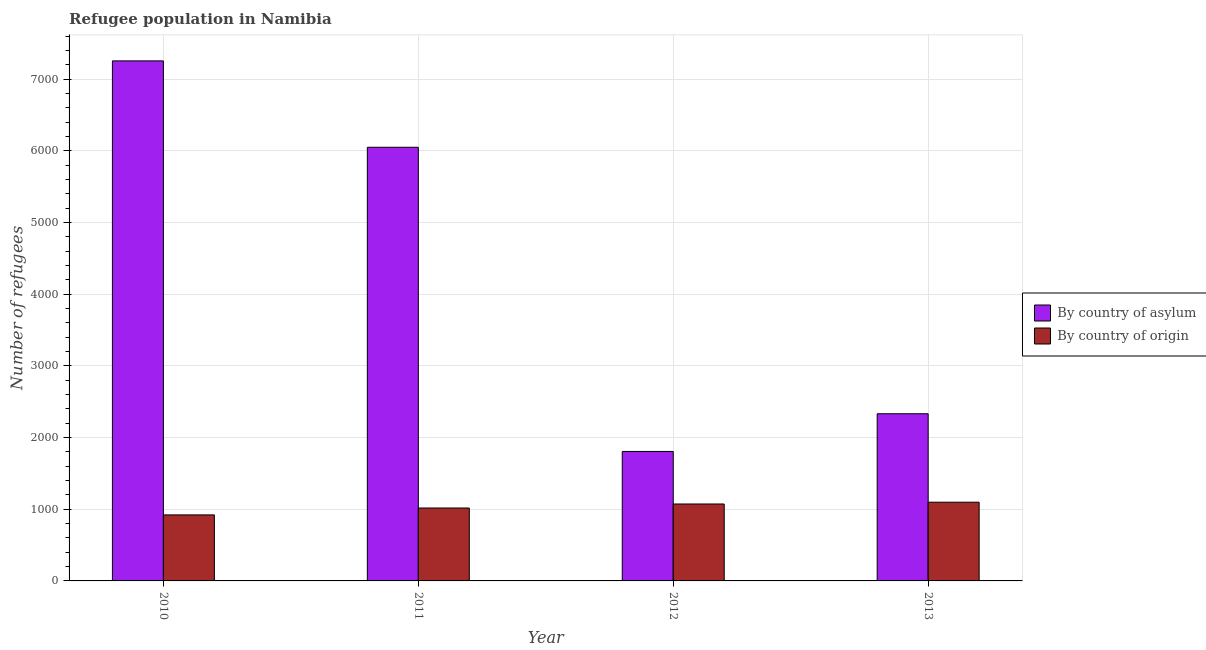How many different coloured bars are there?
Give a very brief answer. 2. Are the number of bars per tick equal to the number of legend labels?
Your answer should be compact. Yes. Are the number of bars on each tick of the X-axis equal?
Ensure brevity in your answer.  Yes. How many bars are there on the 2nd tick from the left?
Keep it short and to the point. 2. How many bars are there on the 1st tick from the right?
Make the answer very short. 2. What is the number of refugees by country of origin in 2010?
Provide a succinct answer. 921. Across all years, what is the maximum number of refugees by country of origin?
Provide a succinct answer. 1098. Across all years, what is the minimum number of refugees by country of asylum?
Your answer should be very brief. 1806. In which year was the number of refugees by country of asylum minimum?
Give a very brief answer. 2012. What is the total number of refugees by country of origin in the graph?
Give a very brief answer. 4109. What is the difference between the number of refugees by country of asylum in 2010 and that in 2012?
Keep it short and to the point. 5448. What is the difference between the number of refugees by country of asylum in 2012 and the number of refugees by country of origin in 2013?
Ensure brevity in your answer.  -526. What is the average number of refugees by country of origin per year?
Give a very brief answer. 1027.25. What is the ratio of the number of refugees by country of origin in 2010 to that in 2012?
Ensure brevity in your answer.  0.86. Is the number of refugees by country of origin in 2010 less than that in 2012?
Your answer should be very brief. Yes. What is the difference between the highest and the lowest number of refugees by country of origin?
Your answer should be compact. 177. What does the 2nd bar from the left in 2013 represents?
Your response must be concise. By country of origin. What does the 2nd bar from the right in 2010 represents?
Ensure brevity in your answer.  By country of asylum. How many bars are there?
Offer a terse response. 8. Are all the bars in the graph horizontal?
Ensure brevity in your answer.  No. What is the difference between two consecutive major ticks on the Y-axis?
Offer a very short reply. 1000. Are the values on the major ticks of Y-axis written in scientific E-notation?
Make the answer very short. No. Does the graph contain any zero values?
Offer a very short reply. No. Does the graph contain grids?
Provide a succinct answer. Yes. How many legend labels are there?
Give a very brief answer. 2. How are the legend labels stacked?
Give a very brief answer. Vertical. What is the title of the graph?
Provide a succinct answer. Refugee population in Namibia. What is the label or title of the Y-axis?
Offer a terse response. Number of refugees. What is the Number of refugees of By country of asylum in 2010?
Offer a terse response. 7254. What is the Number of refugees in By country of origin in 2010?
Provide a short and direct response. 921. What is the Number of refugees of By country of asylum in 2011?
Offer a very short reply. 6049. What is the Number of refugees in By country of origin in 2011?
Provide a short and direct response. 1017. What is the Number of refugees in By country of asylum in 2012?
Offer a terse response. 1806. What is the Number of refugees of By country of origin in 2012?
Your response must be concise. 1073. What is the Number of refugees in By country of asylum in 2013?
Offer a very short reply. 2332. What is the Number of refugees in By country of origin in 2013?
Give a very brief answer. 1098. Across all years, what is the maximum Number of refugees in By country of asylum?
Offer a terse response. 7254. Across all years, what is the maximum Number of refugees of By country of origin?
Your answer should be compact. 1098. Across all years, what is the minimum Number of refugees in By country of asylum?
Give a very brief answer. 1806. Across all years, what is the minimum Number of refugees in By country of origin?
Offer a very short reply. 921. What is the total Number of refugees of By country of asylum in the graph?
Ensure brevity in your answer.  1.74e+04. What is the total Number of refugees of By country of origin in the graph?
Your answer should be compact. 4109. What is the difference between the Number of refugees of By country of asylum in 2010 and that in 2011?
Give a very brief answer. 1205. What is the difference between the Number of refugees of By country of origin in 2010 and that in 2011?
Your answer should be very brief. -96. What is the difference between the Number of refugees of By country of asylum in 2010 and that in 2012?
Your answer should be very brief. 5448. What is the difference between the Number of refugees of By country of origin in 2010 and that in 2012?
Ensure brevity in your answer.  -152. What is the difference between the Number of refugees of By country of asylum in 2010 and that in 2013?
Your answer should be very brief. 4922. What is the difference between the Number of refugees of By country of origin in 2010 and that in 2013?
Your answer should be very brief. -177. What is the difference between the Number of refugees of By country of asylum in 2011 and that in 2012?
Make the answer very short. 4243. What is the difference between the Number of refugees of By country of origin in 2011 and that in 2012?
Your answer should be very brief. -56. What is the difference between the Number of refugees in By country of asylum in 2011 and that in 2013?
Provide a succinct answer. 3717. What is the difference between the Number of refugees in By country of origin in 2011 and that in 2013?
Provide a short and direct response. -81. What is the difference between the Number of refugees of By country of asylum in 2012 and that in 2013?
Your response must be concise. -526. What is the difference between the Number of refugees of By country of asylum in 2010 and the Number of refugees of By country of origin in 2011?
Offer a terse response. 6237. What is the difference between the Number of refugees of By country of asylum in 2010 and the Number of refugees of By country of origin in 2012?
Offer a very short reply. 6181. What is the difference between the Number of refugees in By country of asylum in 2010 and the Number of refugees in By country of origin in 2013?
Make the answer very short. 6156. What is the difference between the Number of refugees in By country of asylum in 2011 and the Number of refugees in By country of origin in 2012?
Your response must be concise. 4976. What is the difference between the Number of refugees in By country of asylum in 2011 and the Number of refugees in By country of origin in 2013?
Keep it short and to the point. 4951. What is the difference between the Number of refugees in By country of asylum in 2012 and the Number of refugees in By country of origin in 2013?
Offer a terse response. 708. What is the average Number of refugees of By country of asylum per year?
Ensure brevity in your answer.  4360.25. What is the average Number of refugees of By country of origin per year?
Give a very brief answer. 1027.25. In the year 2010, what is the difference between the Number of refugees of By country of asylum and Number of refugees of By country of origin?
Offer a terse response. 6333. In the year 2011, what is the difference between the Number of refugees of By country of asylum and Number of refugees of By country of origin?
Give a very brief answer. 5032. In the year 2012, what is the difference between the Number of refugees of By country of asylum and Number of refugees of By country of origin?
Make the answer very short. 733. In the year 2013, what is the difference between the Number of refugees of By country of asylum and Number of refugees of By country of origin?
Ensure brevity in your answer.  1234. What is the ratio of the Number of refugees of By country of asylum in 2010 to that in 2011?
Offer a very short reply. 1.2. What is the ratio of the Number of refugees of By country of origin in 2010 to that in 2011?
Your answer should be compact. 0.91. What is the ratio of the Number of refugees of By country of asylum in 2010 to that in 2012?
Give a very brief answer. 4.02. What is the ratio of the Number of refugees in By country of origin in 2010 to that in 2012?
Provide a succinct answer. 0.86. What is the ratio of the Number of refugees of By country of asylum in 2010 to that in 2013?
Your answer should be compact. 3.11. What is the ratio of the Number of refugees of By country of origin in 2010 to that in 2013?
Give a very brief answer. 0.84. What is the ratio of the Number of refugees of By country of asylum in 2011 to that in 2012?
Offer a very short reply. 3.35. What is the ratio of the Number of refugees in By country of origin in 2011 to that in 2012?
Your answer should be very brief. 0.95. What is the ratio of the Number of refugees of By country of asylum in 2011 to that in 2013?
Offer a very short reply. 2.59. What is the ratio of the Number of refugees in By country of origin in 2011 to that in 2013?
Offer a terse response. 0.93. What is the ratio of the Number of refugees in By country of asylum in 2012 to that in 2013?
Make the answer very short. 0.77. What is the ratio of the Number of refugees in By country of origin in 2012 to that in 2013?
Your answer should be very brief. 0.98. What is the difference between the highest and the second highest Number of refugees of By country of asylum?
Make the answer very short. 1205. What is the difference between the highest and the second highest Number of refugees in By country of origin?
Offer a terse response. 25. What is the difference between the highest and the lowest Number of refugees of By country of asylum?
Your response must be concise. 5448. What is the difference between the highest and the lowest Number of refugees in By country of origin?
Keep it short and to the point. 177. 